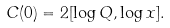Convert formula to latex. <formula><loc_0><loc_0><loc_500><loc_500>C ( 0 ) = 2 [ \log Q , \log x ] .</formula> 